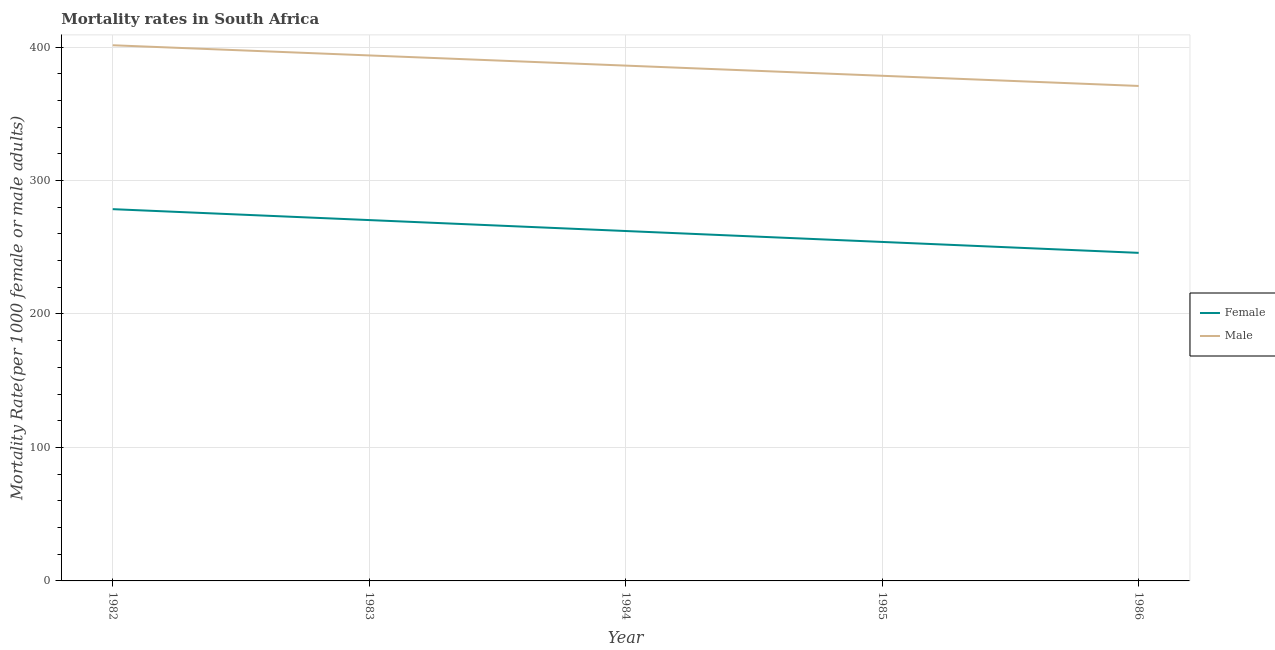How many different coloured lines are there?
Give a very brief answer. 2. Does the line corresponding to female mortality rate intersect with the line corresponding to male mortality rate?
Your answer should be compact. No. What is the male mortality rate in 1984?
Your response must be concise. 386.11. Across all years, what is the maximum male mortality rate?
Provide a short and direct response. 401.36. Across all years, what is the minimum male mortality rate?
Ensure brevity in your answer.  370.86. What is the total male mortality rate in the graph?
Provide a succinct answer. 1930.54. What is the difference between the female mortality rate in 1983 and that in 1984?
Ensure brevity in your answer.  8.19. What is the difference between the female mortality rate in 1985 and the male mortality rate in 1982?
Your answer should be compact. -147.37. What is the average female mortality rate per year?
Your response must be concise. 262.18. In the year 1986, what is the difference between the male mortality rate and female mortality rate?
Provide a succinct answer. 125.06. In how many years, is the female mortality rate greater than 40?
Provide a short and direct response. 5. What is the ratio of the female mortality rate in 1982 to that in 1985?
Offer a very short reply. 1.1. Is the male mortality rate in 1984 less than that in 1986?
Keep it short and to the point. No. Is the difference between the male mortality rate in 1983 and 1985 greater than the difference between the female mortality rate in 1983 and 1985?
Offer a very short reply. No. What is the difference between the highest and the second highest male mortality rate?
Ensure brevity in your answer.  7.62. What is the difference between the highest and the lowest female mortality rate?
Offer a terse response. 32.75. Is the female mortality rate strictly greater than the male mortality rate over the years?
Provide a succinct answer. No. How many lines are there?
Your answer should be very brief. 2. How many years are there in the graph?
Provide a short and direct response. 5. What is the difference between two consecutive major ticks on the Y-axis?
Offer a very short reply. 100. Are the values on the major ticks of Y-axis written in scientific E-notation?
Provide a short and direct response. No. Does the graph contain grids?
Keep it short and to the point. Yes. Where does the legend appear in the graph?
Make the answer very short. Center right. How are the legend labels stacked?
Provide a short and direct response. Vertical. What is the title of the graph?
Provide a succinct answer. Mortality rates in South Africa. Does "Forest land" appear as one of the legend labels in the graph?
Your response must be concise. No. What is the label or title of the Y-axis?
Offer a terse response. Mortality Rate(per 1000 female or male adults). What is the Mortality Rate(per 1000 female or male adults) of Female in 1982?
Your answer should be compact. 278.55. What is the Mortality Rate(per 1000 female or male adults) of Male in 1982?
Your response must be concise. 401.36. What is the Mortality Rate(per 1000 female or male adults) of Female in 1983?
Provide a succinct answer. 270.36. What is the Mortality Rate(per 1000 female or male adults) in Male in 1983?
Ensure brevity in your answer.  393.73. What is the Mortality Rate(per 1000 female or male adults) in Female in 1984?
Your answer should be compact. 262.18. What is the Mortality Rate(per 1000 female or male adults) in Male in 1984?
Offer a very short reply. 386.11. What is the Mortality Rate(per 1000 female or male adults) of Female in 1985?
Offer a terse response. 253.99. What is the Mortality Rate(per 1000 female or male adults) in Male in 1985?
Your answer should be compact. 378.49. What is the Mortality Rate(per 1000 female or male adults) of Female in 1986?
Offer a very short reply. 245.8. What is the Mortality Rate(per 1000 female or male adults) in Male in 1986?
Provide a succinct answer. 370.86. Across all years, what is the maximum Mortality Rate(per 1000 female or male adults) of Female?
Offer a very short reply. 278.55. Across all years, what is the maximum Mortality Rate(per 1000 female or male adults) in Male?
Your answer should be compact. 401.36. Across all years, what is the minimum Mortality Rate(per 1000 female or male adults) of Female?
Your answer should be very brief. 245.8. Across all years, what is the minimum Mortality Rate(per 1000 female or male adults) of Male?
Offer a very short reply. 370.86. What is the total Mortality Rate(per 1000 female or male adults) of Female in the graph?
Make the answer very short. 1310.88. What is the total Mortality Rate(per 1000 female or male adults) in Male in the graph?
Your answer should be very brief. 1930.55. What is the difference between the Mortality Rate(per 1000 female or male adults) of Female in 1982 and that in 1983?
Ensure brevity in your answer.  8.19. What is the difference between the Mortality Rate(per 1000 female or male adults) in Male in 1982 and that in 1983?
Make the answer very short. 7.62. What is the difference between the Mortality Rate(per 1000 female or male adults) of Female in 1982 and that in 1984?
Provide a short and direct response. 16.38. What is the difference between the Mortality Rate(per 1000 female or male adults) in Male in 1982 and that in 1984?
Provide a short and direct response. 15.25. What is the difference between the Mortality Rate(per 1000 female or male adults) of Female in 1982 and that in 1985?
Your answer should be compact. 24.56. What is the difference between the Mortality Rate(per 1000 female or male adults) in Male in 1982 and that in 1985?
Your answer should be very brief. 22.87. What is the difference between the Mortality Rate(per 1000 female or male adults) of Female in 1982 and that in 1986?
Make the answer very short. 32.75. What is the difference between the Mortality Rate(per 1000 female or male adults) in Male in 1982 and that in 1986?
Your answer should be very brief. 30.49. What is the difference between the Mortality Rate(per 1000 female or male adults) of Female in 1983 and that in 1984?
Your answer should be very brief. 8.19. What is the difference between the Mortality Rate(per 1000 female or male adults) of Male in 1983 and that in 1984?
Make the answer very short. 7.62. What is the difference between the Mortality Rate(per 1000 female or male adults) in Female in 1983 and that in 1985?
Your answer should be compact. 16.38. What is the difference between the Mortality Rate(per 1000 female or male adults) in Male in 1983 and that in 1985?
Give a very brief answer. 15.25. What is the difference between the Mortality Rate(per 1000 female or male adults) in Female in 1983 and that in 1986?
Your answer should be compact. 24.56. What is the difference between the Mortality Rate(per 1000 female or male adults) of Male in 1983 and that in 1986?
Offer a very short reply. 22.87. What is the difference between the Mortality Rate(per 1000 female or male adults) in Female in 1984 and that in 1985?
Keep it short and to the point. 8.19. What is the difference between the Mortality Rate(per 1000 female or male adults) of Male in 1984 and that in 1985?
Provide a short and direct response. 7.62. What is the difference between the Mortality Rate(per 1000 female or male adults) in Female in 1984 and that in 1986?
Offer a very short reply. 16.38. What is the difference between the Mortality Rate(per 1000 female or male adults) in Male in 1984 and that in 1986?
Offer a terse response. 15.25. What is the difference between the Mortality Rate(per 1000 female or male adults) in Female in 1985 and that in 1986?
Make the answer very short. 8.19. What is the difference between the Mortality Rate(per 1000 female or male adults) in Male in 1985 and that in 1986?
Offer a terse response. 7.62. What is the difference between the Mortality Rate(per 1000 female or male adults) in Female in 1982 and the Mortality Rate(per 1000 female or male adults) in Male in 1983?
Offer a very short reply. -115.18. What is the difference between the Mortality Rate(per 1000 female or male adults) of Female in 1982 and the Mortality Rate(per 1000 female or male adults) of Male in 1984?
Offer a very short reply. -107.56. What is the difference between the Mortality Rate(per 1000 female or male adults) of Female in 1982 and the Mortality Rate(per 1000 female or male adults) of Male in 1985?
Offer a very short reply. -99.93. What is the difference between the Mortality Rate(per 1000 female or male adults) in Female in 1982 and the Mortality Rate(per 1000 female or male adults) in Male in 1986?
Keep it short and to the point. -92.31. What is the difference between the Mortality Rate(per 1000 female or male adults) in Female in 1983 and the Mortality Rate(per 1000 female or male adults) in Male in 1984?
Your response must be concise. -115.74. What is the difference between the Mortality Rate(per 1000 female or male adults) in Female in 1983 and the Mortality Rate(per 1000 female or male adults) in Male in 1985?
Give a very brief answer. -108.12. What is the difference between the Mortality Rate(per 1000 female or male adults) in Female in 1983 and the Mortality Rate(per 1000 female or male adults) in Male in 1986?
Give a very brief answer. -100.5. What is the difference between the Mortality Rate(per 1000 female or male adults) of Female in 1984 and the Mortality Rate(per 1000 female or male adults) of Male in 1985?
Ensure brevity in your answer.  -116.31. What is the difference between the Mortality Rate(per 1000 female or male adults) of Female in 1984 and the Mortality Rate(per 1000 female or male adults) of Male in 1986?
Give a very brief answer. -108.69. What is the difference between the Mortality Rate(per 1000 female or male adults) in Female in 1985 and the Mortality Rate(per 1000 female or male adults) in Male in 1986?
Provide a short and direct response. -116.87. What is the average Mortality Rate(per 1000 female or male adults) in Female per year?
Your response must be concise. 262.18. What is the average Mortality Rate(per 1000 female or male adults) of Male per year?
Make the answer very short. 386.11. In the year 1982, what is the difference between the Mortality Rate(per 1000 female or male adults) in Female and Mortality Rate(per 1000 female or male adults) in Male?
Your response must be concise. -122.8. In the year 1983, what is the difference between the Mortality Rate(per 1000 female or male adults) of Female and Mortality Rate(per 1000 female or male adults) of Male?
Offer a very short reply. -123.37. In the year 1984, what is the difference between the Mortality Rate(per 1000 female or male adults) of Female and Mortality Rate(per 1000 female or male adults) of Male?
Your answer should be very brief. -123.93. In the year 1985, what is the difference between the Mortality Rate(per 1000 female or male adults) in Female and Mortality Rate(per 1000 female or male adults) in Male?
Offer a very short reply. -124.5. In the year 1986, what is the difference between the Mortality Rate(per 1000 female or male adults) of Female and Mortality Rate(per 1000 female or male adults) of Male?
Offer a terse response. -125.06. What is the ratio of the Mortality Rate(per 1000 female or male adults) in Female in 1982 to that in 1983?
Give a very brief answer. 1.03. What is the ratio of the Mortality Rate(per 1000 female or male adults) of Male in 1982 to that in 1983?
Provide a succinct answer. 1.02. What is the ratio of the Mortality Rate(per 1000 female or male adults) of Female in 1982 to that in 1984?
Your response must be concise. 1.06. What is the ratio of the Mortality Rate(per 1000 female or male adults) of Male in 1982 to that in 1984?
Your answer should be compact. 1.04. What is the ratio of the Mortality Rate(per 1000 female or male adults) of Female in 1982 to that in 1985?
Keep it short and to the point. 1.1. What is the ratio of the Mortality Rate(per 1000 female or male adults) of Male in 1982 to that in 1985?
Your answer should be compact. 1.06. What is the ratio of the Mortality Rate(per 1000 female or male adults) of Female in 1982 to that in 1986?
Offer a terse response. 1.13. What is the ratio of the Mortality Rate(per 1000 female or male adults) in Male in 1982 to that in 1986?
Keep it short and to the point. 1.08. What is the ratio of the Mortality Rate(per 1000 female or male adults) of Female in 1983 to that in 1984?
Ensure brevity in your answer.  1.03. What is the ratio of the Mortality Rate(per 1000 female or male adults) of Male in 1983 to that in 1984?
Ensure brevity in your answer.  1.02. What is the ratio of the Mortality Rate(per 1000 female or male adults) in Female in 1983 to that in 1985?
Give a very brief answer. 1.06. What is the ratio of the Mortality Rate(per 1000 female or male adults) in Male in 1983 to that in 1985?
Your answer should be very brief. 1.04. What is the ratio of the Mortality Rate(per 1000 female or male adults) in Female in 1983 to that in 1986?
Your answer should be very brief. 1.1. What is the ratio of the Mortality Rate(per 1000 female or male adults) of Male in 1983 to that in 1986?
Your response must be concise. 1.06. What is the ratio of the Mortality Rate(per 1000 female or male adults) in Female in 1984 to that in 1985?
Make the answer very short. 1.03. What is the ratio of the Mortality Rate(per 1000 female or male adults) of Male in 1984 to that in 1985?
Offer a terse response. 1.02. What is the ratio of the Mortality Rate(per 1000 female or male adults) in Female in 1984 to that in 1986?
Your answer should be very brief. 1.07. What is the ratio of the Mortality Rate(per 1000 female or male adults) of Male in 1984 to that in 1986?
Your answer should be compact. 1.04. What is the ratio of the Mortality Rate(per 1000 female or male adults) of Male in 1985 to that in 1986?
Offer a terse response. 1.02. What is the difference between the highest and the second highest Mortality Rate(per 1000 female or male adults) of Female?
Your answer should be very brief. 8.19. What is the difference between the highest and the second highest Mortality Rate(per 1000 female or male adults) in Male?
Your answer should be very brief. 7.62. What is the difference between the highest and the lowest Mortality Rate(per 1000 female or male adults) in Female?
Ensure brevity in your answer.  32.75. What is the difference between the highest and the lowest Mortality Rate(per 1000 female or male adults) in Male?
Provide a short and direct response. 30.49. 